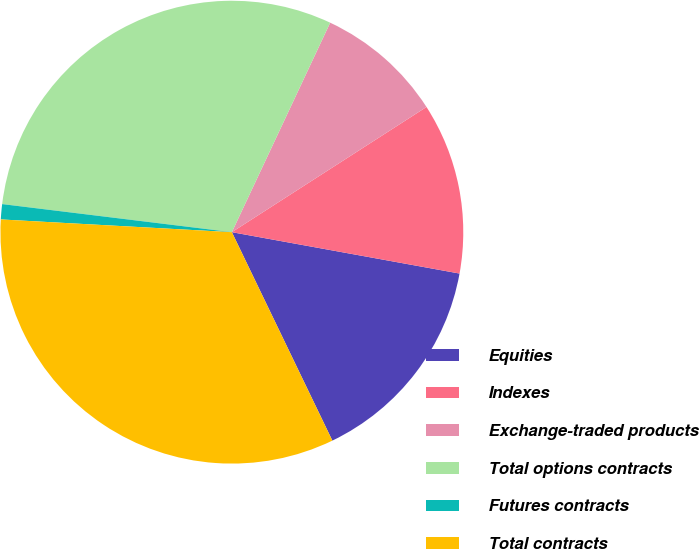Convert chart to OTSL. <chart><loc_0><loc_0><loc_500><loc_500><pie_chart><fcel>Equities<fcel>Indexes<fcel>Exchange-traded products<fcel>Total options contracts<fcel>Futures contracts<fcel>Total contracts<nl><fcel>14.99%<fcel>11.96%<fcel>8.92%<fcel>30.05%<fcel>1.06%<fcel>33.03%<nl></chart> 